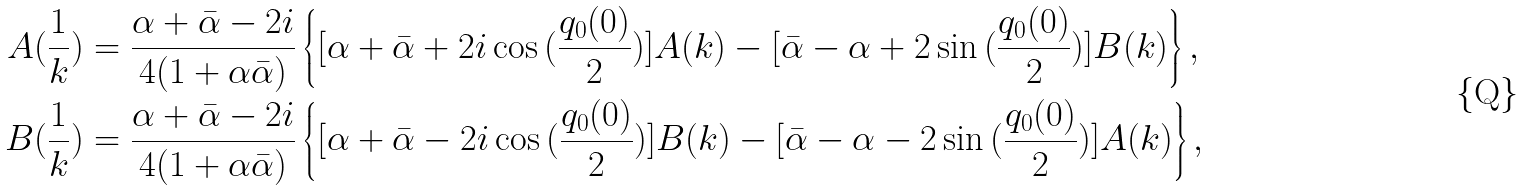<formula> <loc_0><loc_0><loc_500><loc_500>A ( \frac { 1 } { k } ) & = \frac { \alpha + \bar { \alpha } - 2 i } { 4 ( 1 + \alpha \bar { \alpha } ) } \left \{ [ \alpha + \bar { \alpha } + 2 i \cos { ( \frac { q _ { 0 } ( 0 ) } { 2 } ) } ] A ( k ) - [ \bar { \alpha } - \alpha + 2 \sin { ( \frac { q _ { 0 } ( 0 ) } { 2 } ) } ] B ( k ) \right \} , \\ B ( \frac { 1 } { k } ) & = \frac { \alpha + \bar { \alpha } - 2 i } { 4 ( 1 + \alpha \bar { \alpha } ) } \left \{ [ \alpha + \bar { \alpha } - 2 i \cos { ( \frac { q _ { 0 } ( 0 ) } { 2 } ) } ] B ( k ) - [ \bar { \alpha } - \alpha - 2 \sin { ( \frac { q _ { 0 } ( 0 ) } { 2 } ) } ] A ( k ) \right \} ,</formula> 